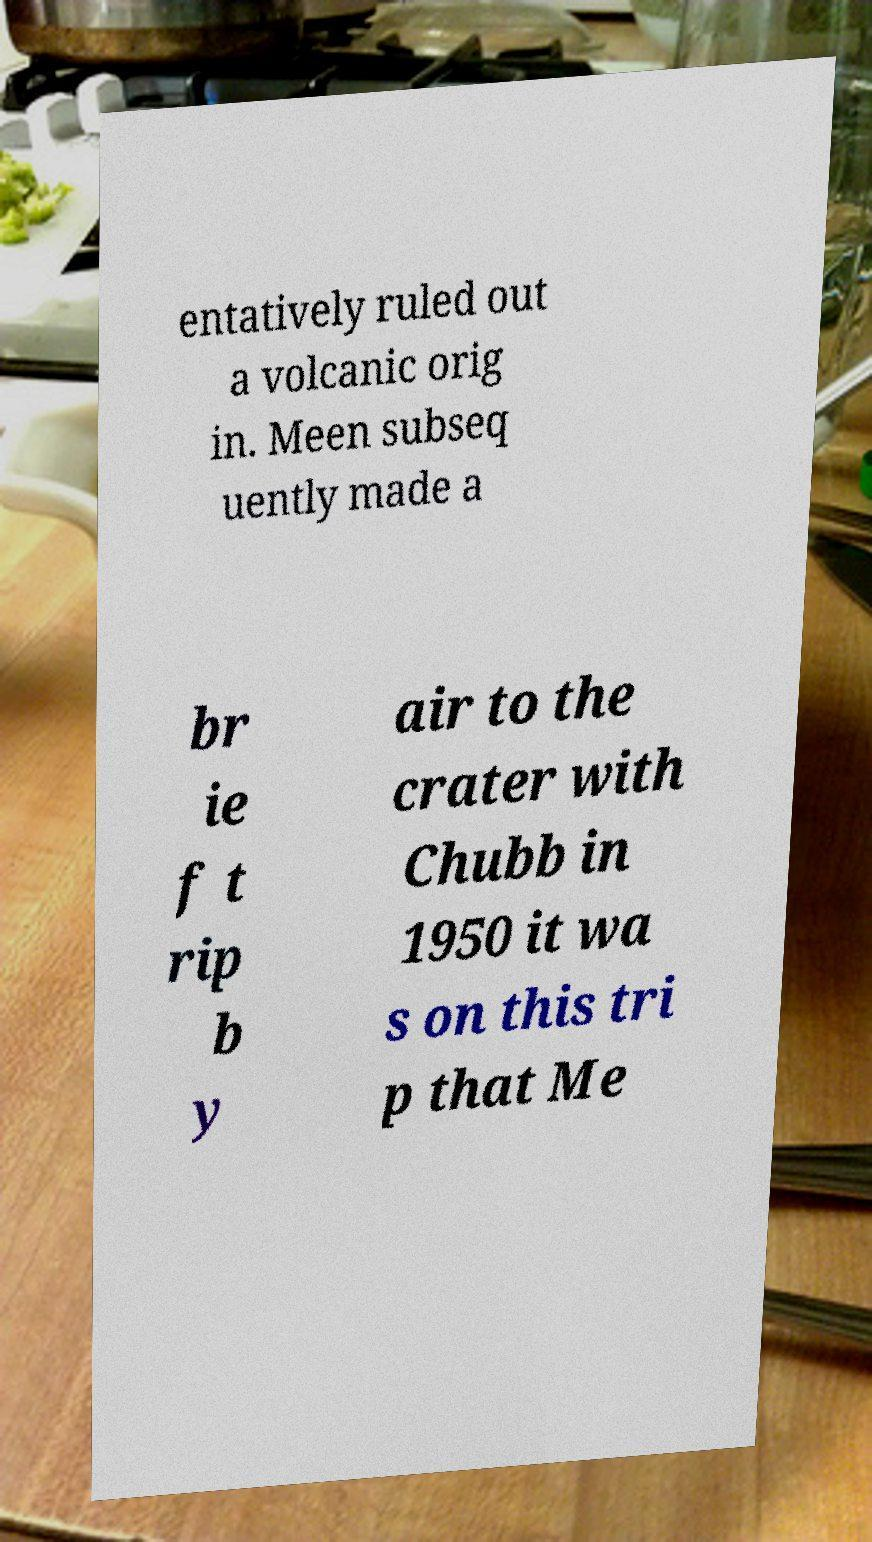What messages or text are displayed in this image? I need them in a readable, typed format. entatively ruled out a volcanic orig in. Meen subseq uently made a br ie f t rip b y air to the crater with Chubb in 1950 it wa s on this tri p that Me 